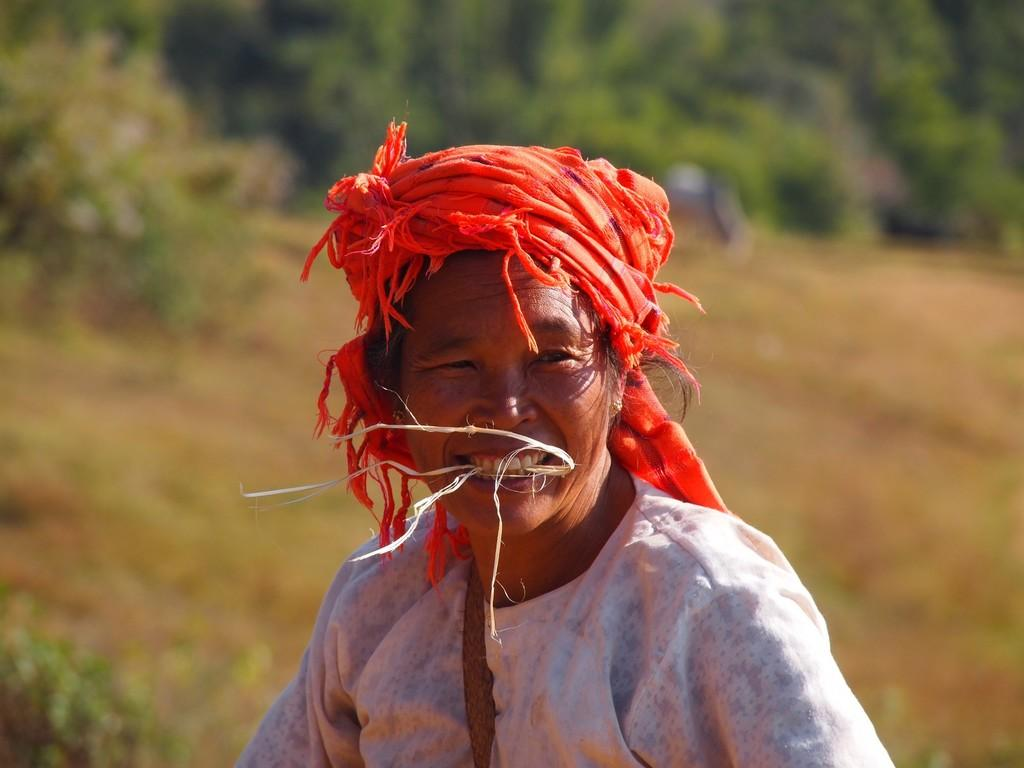What is present in the image? There is a person in the image. What can be seen in the background of the image? There are trees in the background of the image. How would you describe the quality of the image? The image is blurry. What type of ornament is hanging from the person's neck in the image? There is no ornament visible around the person's neck in the image. How does the person feel in the image? The image does not convey any specific feelings or emotions of the person, as it is blurry and does not show facial expressions clearly. 